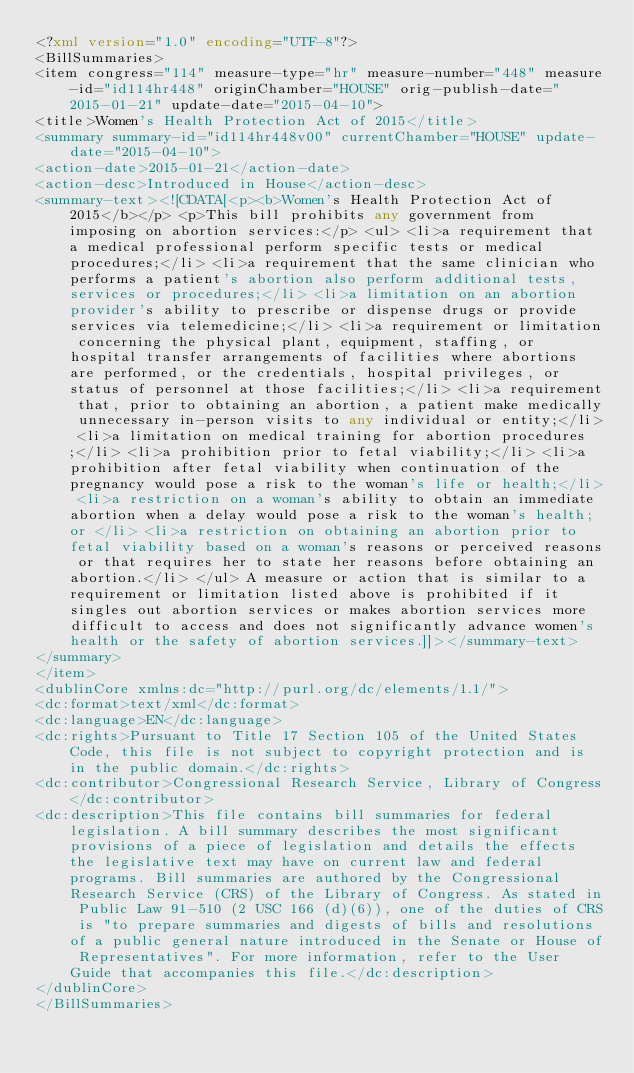<code> <loc_0><loc_0><loc_500><loc_500><_XML_><?xml version="1.0" encoding="UTF-8"?>
<BillSummaries>
<item congress="114" measure-type="hr" measure-number="448" measure-id="id114hr448" originChamber="HOUSE" orig-publish-date="2015-01-21" update-date="2015-04-10">
<title>Women's Health Protection Act of 2015</title>
<summary summary-id="id114hr448v00" currentChamber="HOUSE" update-date="2015-04-10">
<action-date>2015-01-21</action-date>
<action-desc>Introduced in House</action-desc>
<summary-text><![CDATA[<p><b>Women's Health Protection Act of 2015</b></p> <p>This bill prohibits any government from imposing on abortion services:</p> <ul> <li>a requirement that a medical professional perform specific tests or medical procedures;</li> <li>a requirement that the same clinician who performs a patient's abortion also perform additional tests, services or procedures;</li> <li>a limitation on an abortion provider's ability to prescribe or dispense drugs or provide services via telemedicine;</li> <li>a requirement or limitation concerning the physical plant, equipment, staffing, or hospital transfer arrangements of facilities where abortions are performed, or the credentials, hospital privileges, or status of personnel at those facilities;</li> <li>a requirement that, prior to obtaining an abortion, a patient make medically unnecessary in-person visits to any individual or entity;</li> <li>a limitation on medical training for abortion procedures;</li> <li>a prohibition prior to fetal viability;</li> <li>a prohibition after fetal viability when continuation of the pregnancy would pose a risk to the woman's life or health;</li> <li>a restriction on a woman's ability to obtain an immediate abortion when a delay would pose a risk to the woman's health; or </li> <li>a restriction on obtaining an abortion prior to fetal viability based on a woman's reasons or perceived reasons or that requires her to state her reasons before obtaining an abortion.</li> </ul> A measure or action that is similar to a requirement or limitation listed above is prohibited if it singles out abortion services or makes abortion services more difficult to access and does not significantly advance women's health or the safety of abortion services.]]></summary-text>
</summary>
</item>
<dublinCore xmlns:dc="http://purl.org/dc/elements/1.1/">
<dc:format>text/xml</dc:format>
<dc:language>EN</dc:language>
<dc:rights>Pursuant to Title 17 Section 105 of the United States Code, this file is not subject to copyright protection and is in the public domain.</dc:rights>
<dc:contributor>Congressional Research Service, Library of Congress</dc:contributor>
<dc:description>This file contains bill summaries for federal legislation. A bill summary describes the most significant provisions of a piece of legislation and details the effects the legislative text may have on current law and federal programs. Bill summaries are authored by the Congressional Research Service (CRS) of the Library of Congress. As stated in Public Law 91-510 (2 USC 166 (d)(6)), one of the duties of CRS is "to prepare summaries and digests of bills and resolutions of a public general nature introduced in the Senate or House of Representatives". For more information, refer to the User Guide that accompanies this file.</dc:description>
</dublinCore>
</BillSummaries>
</code> 